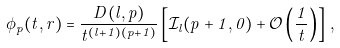<formula> <loc_0><loc_0><loc_500><loc_500>\phi _ { p } ( t , r ) = \frac { D ( l , p ) } { t ^ { ( l + 1 ) ( p + 1 ) } } \left [ \mathcal { I } _ { l } ( p + 1 , 0 ) + \mathcal { O } \left ( \frac { 1 } { t } \right ) \right ] \, ,</formula> 